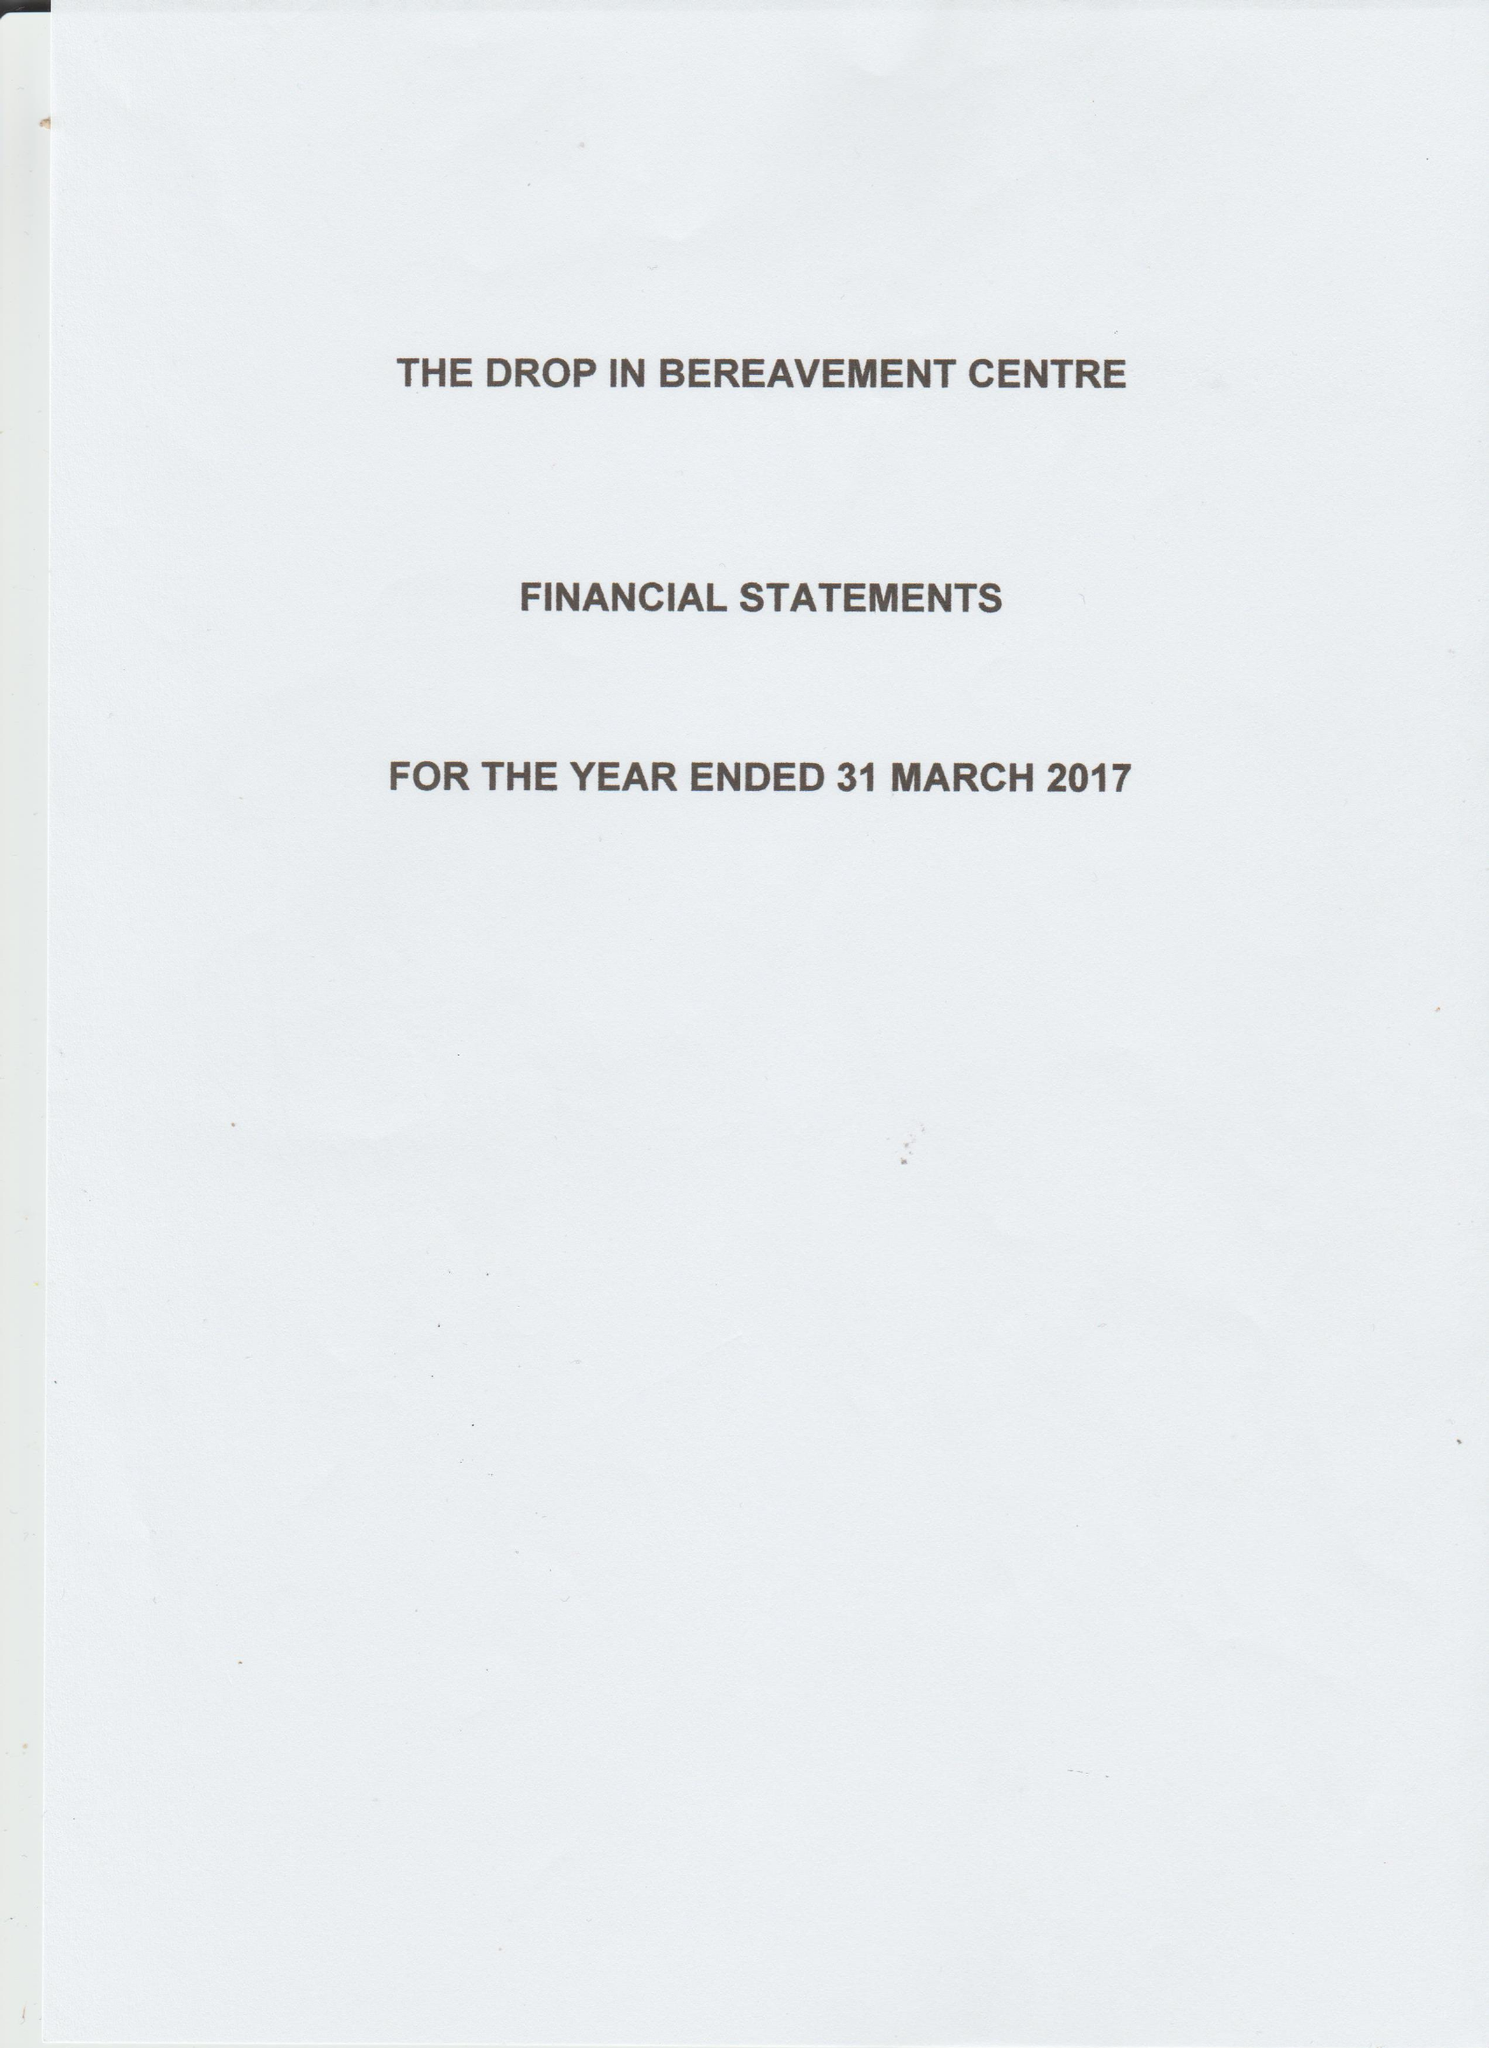What is the value for the charity_number?
Answer the question using a single word or phrase. 1161526 